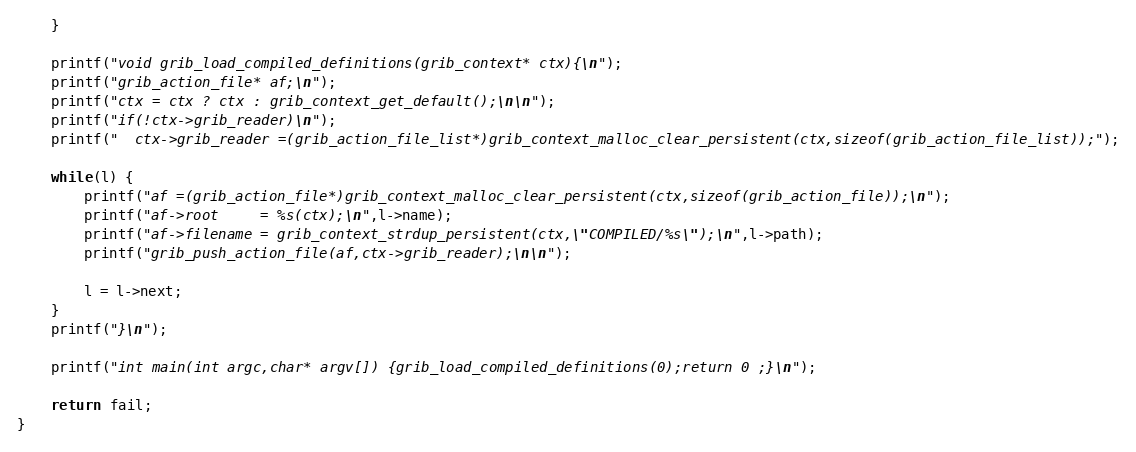Convert code to text. <code><loc_0><loc_0><loc_500><loc_500><_C_>    }

    printf("void grib_load_compiled_definitions(grib_context* ctx){\n");
    printf("grib_action_file* af;\n");
    printf("ctx = ctx ? ctx : grib_context_get_default();\n\n");
	printf("if(!ctx->grib_reader)\n");
	printf("  ctx->grib_reader =(grib_action_file_list*)grib_context_malloc_clear_persistent(ctx,sizeof(grib_action_file_list));");

    while(l) {
        printf("af =(grib_action_file*)grib_context_malloc_clear_persistent(ctx,sizeof(grib_action_file));\n");
        printf("af->root     = %s(ctx);\n",l->name);
        printf("af->filename = grib_context_strdup_persistent(ctx,\"COMPILED/%s\");\n",l->path);
        printf("grib_push_action_file(af,ctx->grib_reader);\n\n");

        l = l->next;
    }
    printf("}\n");

	printf("int main(int argc,char* argv[]) {grib_load_compiled_definitions(0);return 0 ;}\n");

    return fail;
}
</code> 